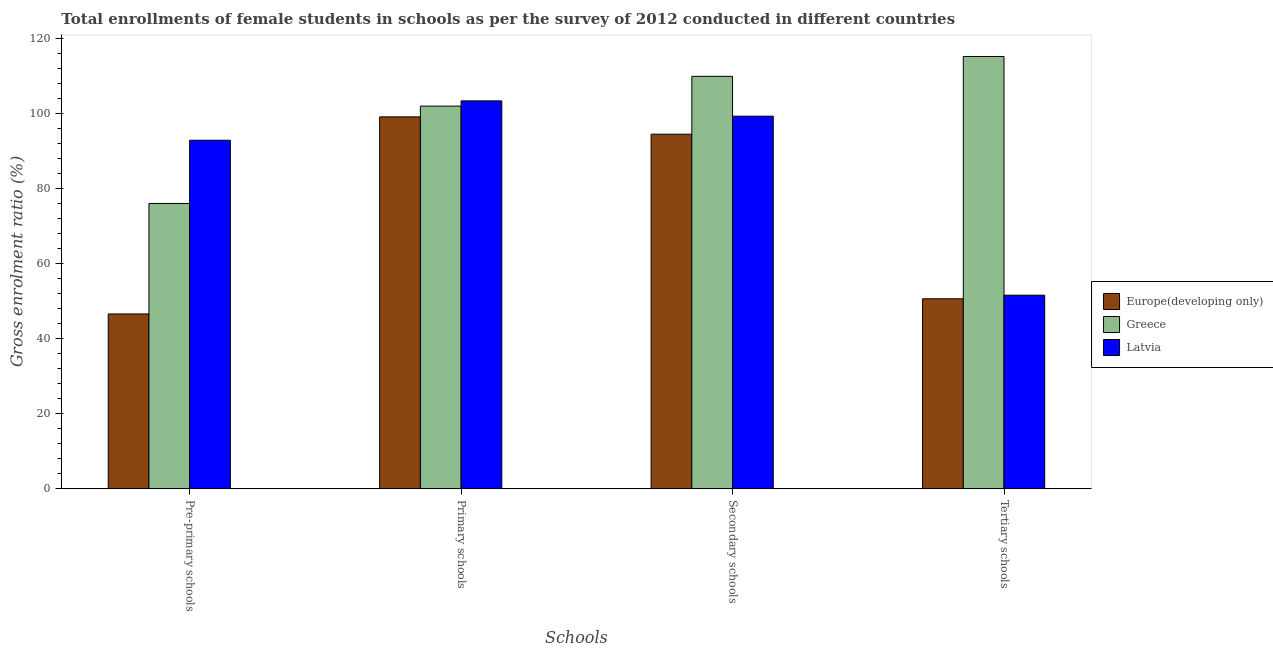How many groups of bars are there?
Keep it short and to the point. 4. Are the number of bars per tick equal to the number of legend labels?
Ensure brevity in your answer.  Yes. Are the number of bars on each tick of the X-axis equal?
Your answer should be compact. Yes. How many bars are there on the 3rd tick from the right?
Offer a terse response. 3. What is the label of the 2nd group of bars from the left?
Your answer should be very brief. Primary schools. What is the gross enrolment ratio(female) in tertiary schools in Latvia?
Make the answer very short. 51.59. Across all countries, what is the maximum gross enrolment ratio(female) in primary schools?
Provide a short and direct response. 103.39. Across all countries, what is the minimum gross enrolment ratio(female) in pre-primary schools?
Provide a short and direct response. 46.59. In which country was the gross enrolment ratio(female) in secondary schools maximum?
Your answer should be compact. Greece. In which country was the gross enrolment ratio(female) in primary schools minimum?
Give a very brief answer. Europe(developing only). What is the total gross enrolment ratio(female) in secondary schools in the graph?
Provide a short and direct response. 303.76. What is the difference between the gross enrolment ratio(female) in primary schools in Europe(developing only) and that in Latvia?
Provide a short and direct response. -4.27. What is the difference between the gross enrolment ratio(female) in pre-primary schools in Latvia and the gross enrolment ratio(female) in primary schools in Greece?
Your response must be concise. -9.1. What is the average gross enrolment ratio(female) in pre-primary schools per country?
Your response must be concise. 71.84. What is the difference between the gross enrolment ratio(female) in tertiary schools and gross enrolment ratio(female) in pre-primary schools in Greece?
Ensure brevity in your answer.  39.19. What is the ratio of the gross enrolment ratio(female) in tertiary schools in Greece to that in Europe(developing only)?
Offer a very short reply. 2.28. Is the difference between the gross enrolment ratio(female) in pre-primary schools in Latvia and Europe(developing only) greater than the difference between the gross enrolment ratio(female) in tertiary schools in Latvia and Europe(developing only)?
Provide a short and direct response. Yes. What is the difference between the highest and the second highest gross enrolment ratio(female) in pre-primary schools?
Offer a terse response. 16.85. What is the difference between the highest and the lowest gross enrolment ratio(female) in tertiary schools?
Your response must be concise. 64.6. In how many countries, is the gross enrolment ratio(female) in tertiary schools greater than the average gross enrolment ratio(female) in tertiary schools taken over all countries?
Your answer should be very brief. 1. Is it the case that in every country, the sum of the gross enrolment ratio(female) in tertiary schools and gross enrolment ratio(female) in secondary schools is greater than the sum of gross enrolment ratio(female) in primary schools and gross enrolment ratio(female) in pre-primary schools?
Provide a succinct answer. Yes. What does the 1st bar from the left in Pre-primary schools represents?
Provide a short and direct response. Europe(developing only). What does the 3rd bar from the right in Secondary schools represents?
Your answer should be compact. Europe(developing only). Is it the case that in every country, the sum of the gross enrolment ratio(female) in pre-primary schools and gross enrolment ratio(female) in primary schools is greater than the gross enrolment ratio(female) in secondary schools?
Offer a very short reply. Yes. What is the difference between two consecutive major ticks on the Y-axis?
Your answer should be compact. 20. Does the graph contain any zero values?
Offer a very short reply. No. How are the legend labels stacked?
Your answer should be very brief. Vertical. What is the title of the graph?
Provide a short and direct response. Total enrollments of female students in schools as per the survey of 2012 conducted in different countries. Does "Vanuatu" appear as one of the legend labels in the graph?
Keep it short and to the point. No. What is the label or title of the X-axis?
Give a very brief answer. Schools. What is the label or title of the Y-axis?
Make the answer very short. Gross enrolment ratio (%). What is the Gross enrolment ratio (%) of Europe(developing only) in Pre-primary schools?
Your response must be concise. 46.59. What is the Gross enrolment ratio (%) in Greece in Pre-primary schools?
Make the answer very short. 76.04. What is the Gross enrolment ratio (%) in Latvia in Pre-primary schools?
Provide a succinct answer. 92.9. What is the Gross enrolment ratio (%) of Europe(developing only) in Primary schools?
Ensure brevity in your answer.  99.13. What is the Gross enrolment ratio (%) in Greece in Primary schools?
Your response must be concise. 102. What is the Gross enrolment ratio (%) in Latvia in Primary schools?
Provide a succinct answer. 103.39. What is the Gross enrolment ratio (%) of Europe(developing only) in Secondary schools?
Provide a short and direct response. 94.52. What is the Gross enrolment ratio (%) of Greece in Secondary schools?
Your response must be concise. 109.94. What is the Gross enrolment ratio (%) in Latvia in Secondary schools?
Ensure brevity in your answer.  99.31. What is the Gross enrolment ratio (%) in Europe(developing only) in Tertiary schools?
Ensure brevity in your answer.  50.63. What is the Gross enrolment ratio (%) of Greece in Tertiary schools?
Offer a very short reply. 115.23. What is the Gross enrolment ratio (%) in Latvia in Tertiary schools?
Keep it short and to the point. 51.59. Across all Schools, what is the maximum Gross enrolment ratio (%) in Europe(developing only)?
Keep it short and to the point. 99.13. Across all Schools, what is the maximum Gross enrolment ratio (%) of Greece?
Your answer should be compact. 115.23. Across all Schools, what is the maximum Gross enrolment ratio (%) of Latvia?
Offer a very short reply. 103.39. Across all Schools, what is the minimum Gross enrolment ratio (%) in Europe(developing only)?
Offer a terse response. 46.59. Across all Schools, what is the minimum Gross enrolment ratio (%) in Greece?
Ensure brevity in your answer.  76.04. Across all Schools, what is the minimum Gross enrolment ratio (%) in Latvia?
Provide a short and direct response. 51.59. What is the total Gross enrolment ratio (%) of Europe(developing only) in the graph?
Make the answer very short. 290.86. What is the total Gross enrolment ratio (%) in Greece in the graph?
Offer a terse response. 403.21. What is the total Gross enrolment ratio (%) in Latvia in the graph?
Ensure brevity in your answer.  347.19. What is the difference between the Gross enrolment ratio (%) of Europe(developing only) in Pre-primary schools and that in Primary schools?
Make the answer very short. -52.54. What is the difference between the Gross enrolment ratio (%) in Greece in Pre-primary schools and that in Primary schools?
Offer a terse response. -25.96. What is the difference between the Gross enrolment ratio (%) in Latvia in Pre-primary schools and that in Primary schools?
Provide a short and direct response. -10.5. What is the difference between the Gross enrolment ratio (%) in Europe(developing only) in Pre-primary schools and that in Secondary schools?
Offer a terse response. -47.93. What is the difference between the Gross enrolment ratio (%) of Greece in Pre-primary schools and that in Secondary schools?
Your answer should be very brief. -33.89. What is the difference between the Gross enrolment ratio (%) of Latvia in Pre-primary schools and that in Secondary schools?
Offer a very short reply. -6.41. What is the difference between the Gross enrolment ratio (%) of Europe(developing only) in Pre-primary schools and that in Tertiary schools?
Provide a succinct answer. -4.05. What is the difference between the Gross enrolment ratio (%) of Greece in Pre-primary schools and that in Tertiary schools?
Give a very brief answer. -39.19. What is the difference between the Gross enrolment ratio (%) of Latvia in Pre-primary schools and that in Tertiary schools?
Make the answer very short. 41.31. What is the difference between the Gross enrolment ratio (%) of Europe(developing only) in Primary schools and that in Secondary schools?
Provide a short and direct response. 4.61. What is the difference between the Gross enrolment ratio (%) in Greece in Primary schools and that in Secondary schools?
Give a very brief answer. -7.94. What is the difference between the Gross enrolment ratio (%) in Latvia in Primary schools and that in Secondary schools?
Your answer should be very brief. 4.08. What is the difference between the Gross enrolment ratio (%) in Europe(developing only) in Primary schools and that in Tertiary schools?
Your answer should be compact. 48.5. What is the difference between the Gross enrolment ratio (%) of Greece in Primary schools and that in Tertiary schools?
Provide a succinct answer. -13.23. What is the difference between the Gross enrolment ratio (%) in Latvia in Primary schools and that in Tertiary schools?
Your response must be concise. 51.81. What is the difference between the Gross enrolment ratio (%) of Europe(developing only) in Secondary schools and that in Tertiary schools?
Provide a short and direct response. 43.88. What is the difference between the Gross enrolment ratio (%) in Greece in Secondary schools and that in Tertiary schools?
Your answer should be very brief. -5.29. What is the difference between the Gross enrolment ratio (%) of Latvia in Secondary schools and that in Tertiary schools?
Give a very brief answer. 47.72. What is the difference between the Gross enrolment ratio (%) of Europe(developing only) in Pre-primary schools and the Gross enrolment ratio (%) of Greece in Primary schools?
Make the answer very short. -55.42. What is the difference between the Gross enrolment ratio (%) in Europe(developing only) in Pre-primary schools and the Gross enrolment ratio (%) in Latvia in Primary schools?
Offer a very short reply. -56.81. What is the difference between the Gross enrolment ratio (%) in Greece in Pre-primary schools and the Gross enrolment ratio (%) in Latvia in Primary schools?
Provide a succinct answer. -27.35. What is the difference between the Gross enrolment ratio (%) in Europe(developing only) in Pre-primary schools and the Gross enrolment ratio (%) in Greece in Secondary schools?
Offer a very short reply. -63.35. What is the difference between the Gross enrolment ratio (%) in Europe(developing only) in Pre-primary schools and the Gross enrolment ratio (%) in Latvia in Secondary schools?
Keep it short and to the point. -52.72. What is the difference between the Gross enrolment ratio (%) of Greece in Pre-primary schools and the Gross enrolment ratio (%) of Latvia in Secondary schools?
Your response must be concise. -23.27. What is the difference between the Gross enrolment ratio (%) in Europe(developing only) in Pre-primary schools and the Gross enrolment ratio (%) in Greece in Tertiary schools?
Your answer should be compact. -68.64. What is the difference between the Gross enrolment ratio (%) in Europe(developing only) in Pre-primary schools and the Gross enrolment ratio (%) in Latvia in Tertiary schools?
Ensure brevity in your answer.  -5. What is the difference between the Gross enrolment ratio (%) in Greece in Pre-primary schools and the Gross enrolment ratio (%) in Latvia in Tertiary schools?
Give a very brief answer. 24.46. What is the difference between the Gross enrolment ratio (%) in Europe(developing only) in Primary schools and the Gross enrolment ratio (%) in Greece in Secondary schools?
Provide a short and direct response. -10.81. What is the difference between the Gross enrolment ratio (%) in Europe(developing only) in Primary schools and the Gross enrolment ratio (%) in Latvia in Secondary schools?
Your answer should be compact. -0.18. What is the difference between the Gross enrolment ratio (%) in Greece in Primary schools and the Gross enrolment ratio (%) in Latvia in Secondary schools?
Provide a succinct answer. 2.69. What is the difference between the Gross enrolment ratio (%) in Europe(developing only) in Primary schools and the Gross enrolment ratio (%) in Greece in Tertiary schools?
Make the answer very short. -16.1. What is the difference between the Gross enrolment ratio (%) in Europe(developing only) in Primary schools and the Gross enrolment ratio (%) in Latvia in Tertiary schools?
Provide a succinct answer. 47.54. What is the difference between the Gross enrolment ratio (%) of Greece in Primary schools and the Gross enrolment ratio (%) of Latvia in Tertiary schools?
Give a very brief answer. 50.41. What is the difference between the Gross enrolment ratio (%) in Europe(developing only) in Secondary schools and the Gross enrolment ratio (%) in Greece in Tertiary schools?
Keep it short and to the point. -20.72. What is the difference between the Gross enrolment ratio (%) in Europe(developing only) in Secondary schools and the Gross enrolment ratio (%) in Latvia in Tertiary schools?
Your response must be concise. 42.93. What is the difference between the Gross enrolment ratio (%) of Greece in Secondary schools and the Gross enrolment ratio (%) of Latvia in Tertiary schools?
Give a very brief answer. 58.35. What is the average Gross enrolment ratio (%) in Europe(developing only) per Schools?
Make the answer very short. 72.72. What is the average Gross enrolment ratio (%) of Greece per Schools?
Your answer should be compact. 100.8. What is the average Gross enrolment ratio (%) in Latvia per Schools?
Offer a terse response. 86.8. What is the difference between the Gross enrolment ratio (%) of Europe(developing only) and Gross enrolment ratio (%) of Greece in Pre-primary schools?
Ensure brevity in your answer.  -29.46. What is the difference between the Gross enrolment ratio (%) in Europe(developing only) and Gross enrolment ratio (%) in Latvia in Pre-primary schools?
Your answer should be compact. -46.31. What is the difference between the Gross enrolment ratio (%) in Greece and Gross enrolment ratio (%) in Latvia in Pre-primary schools?
Keep it short and to the point. -16.85. What is the difference between the Gross enrolment ratio (%) of Europe(developing only) and Gross enrolment ratio (%) of Greece in Primary schools?
Provide a succinct answer. -2.87. What is the difference between the Gross enrolment ratio (%) in Europe(developing only) and Gross enrolment ratio (%) in Latvia in Primary schools?
Keep it short and to the point. -4.27. What is the difference between the Gross enrolment ratio (%) in Greece and Gross enrolment ratio (%) in Latvia in Primary schools?
Provide a short and direct response. -1.39. What is the difference between the Gross enrolment ratio (%) in Europe(developing only) and Gross enrolment ratio (%) in Greece in Secondary schools?
Your response must be concise. -15.42. What is the difference between the Gross enrolment ratio (%) in Europe(developing only) and Gross enrolment ratio (%) in Latvia in Secondary schools?
Offer a very short reply. -4.79. What is the difference between the Gross enrolment ratio (%) of Greece and Gross enrolment ratio (%) of Latvia in Secondary schools?
Ensure brevity in your answer.  10.63. What is the difference between the Gross enrolment ratio (%) of Europe(developing only) and Gross enrolment ratio (%) of Greece in Tertiary schools?
Offer a terse response. -64.6. What is the difference between the Gross enrolment ratio (%) in Europe(developing only) and Gross enrolment ratio (%) in Latvia in Tertiary schools?
Make the answer very short. -0.96. What is the difference between the Gross enrolment ratio (%) of Greece and Gross enrolment ratio (%) of Latvia in Tertiary schools?
Make the answer very short. 63.64. What is the ratio of the Gross enrolment ratio (%) in Europe(developing only) in Pre-primary schools to that in Primary schools?
Ensure brevity in your answer.  0.47. What is the ratio of the Gross enrolment ratio (%) in Greece in Pre-primary schools to that in Primary schools?
Provide a succinct answer. 0.75. What is the ratio of the Gross enrolment ratio (%) in Latvia in Pre-primary schools to that in Primary schools?
Your answer should be compact. 0.9. What is the ratio of the Gross enrolment ratio (%) of Europe(developing only) in Pre-primary schools to that in Secondary schools?
Give a very brief answer. 0.49. What is the ratio of the Gross enrolment ratio (%) of Greece in Pre-primary schools to that in Secondary schools?
Ensure brevity in your answer.  0.69. What is the ratio of the Gross enrolment ratio (%) in Latvia in Pre-primary schools to that in Secondary schools?
Your answer should be very brief. 0.94. What is the ratio of the Gross enrolment ratio (%) in Europe(developing only) in Pre-primary schools to that in Tertiary schools?
Your response must be concise. 0.92. What is the ratio of the Gross enrolment ratio (%) in Greece in Pre-primary schools to that in Tertiary schools?
Provide a succinct answer. 0.66. What is the ratio of the Gross enrolment ratio (%) in Latvia in Pre-primary schools to that in Tertiary schools?
Offer a terse response. 1.8. What is the ratio of the Gross enrolment ratio (%) in Europe(developing only) in Primary schools to that in Secondary schools?
Give a very brief answer. 1.05. What is the ratio of the Gross enrolment ratio (%) in Greece in Primary schools to that in Secondary schools?
Your answer should be compact. 0.93. What is the ratio of the Gross enrolment ratio (%) in Latvia in Primary schools to that in Secondary schools?
Your response must be concise. 1.04. What is the ratio of the Gross enrolment ratio (%) in Europe(developing only) in Primary schools to that in Tertiary schools?
Provide a succinct answer. 1.96. What is the ratio of the Gross enrolment ratio (%) in Greece in Primary schools to that in Tertiary schools?
Your answer should be compact. 0.89. What is the ratio of the Gross enrolment ratio (%) in Latvia in Primary schools to that in Tertiary schools?
Offer a terse response. 2. What is the ratio of the Gross enrolment ratio (%) in Europe(developing only) in Secondary schools to that in Tertiary schools?
Ensure brevity in your answer.  1.87. What is the ratio of the Gross enrolment ratio (%) in Greece in Secondary schools to that in Tertiary schools?
Offer a very short reply. 0.95. What is the ratio of the Gross enrolment ratio (%) of Latvia in Secondary schools to that in Tertiary schools?
Your answer should be compact. 1.93. What is the difference between the highest and the second highest Gross enrolment ratio (%) in Europe(developing only)?
Offer a very short reply. 4.61. What is the difference between the highest and the second highest Gross enrolment ratio (%) in Greece?
Provide a short and direct response. 5.29. What is the difference between the highest and the second highest Gross enrolment ratio (%) of Latvia?
Offer a terse response. 4.08. What is the difference between the highest and the lowest Gross enrolment ratio (%) in Europe(developing only)?
Keep it short and to the point. 52.54. What is the difference between the highest and the lowest Gross enrolment ratio (%) of Greece?
Your answer should be compact. 39.19. What is the difference between the highest and the lowest Gross enrolment ratio (%) in Latvia?
Make the answer very short. 51.81. 